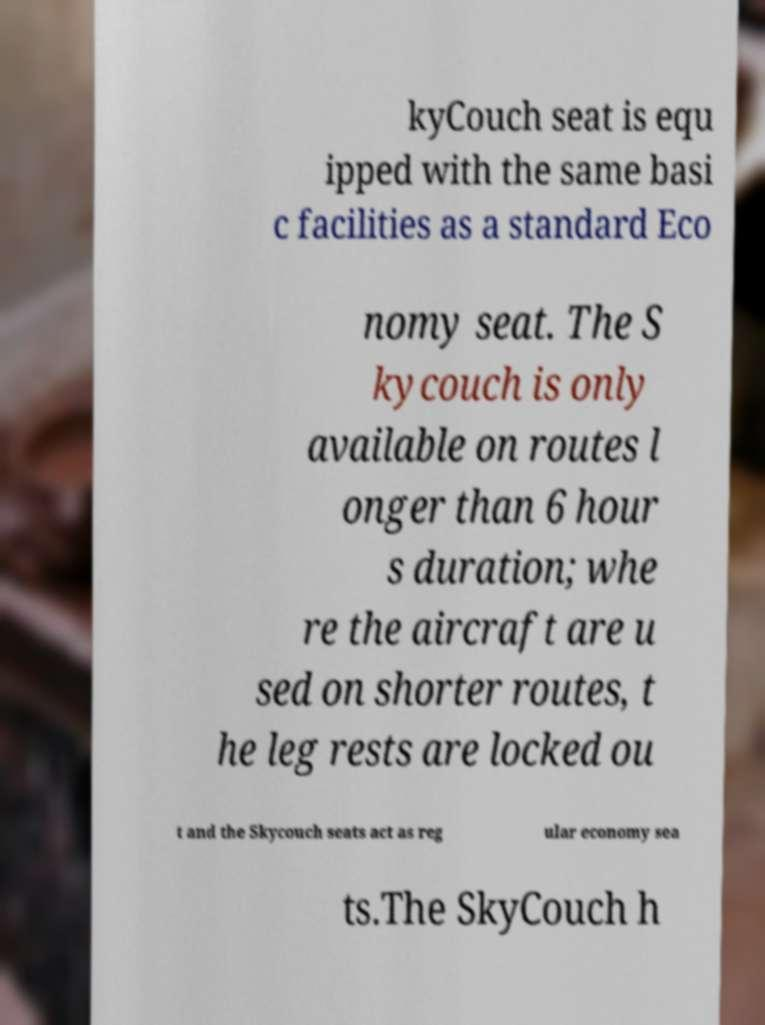Please read and relay the text visible in this image. What does it say? kyCouch seat is equ ipped with the same basi c facilities as a standard Eco nomy seat. The S kycouch is only available on routes l onger than 6 hour s duration; whe re the aircraft are u sed on shorter routes, t he leg rests are locked ou t and the Skycouch seats act as reg ular economy sea ts.The SkyCouch h 